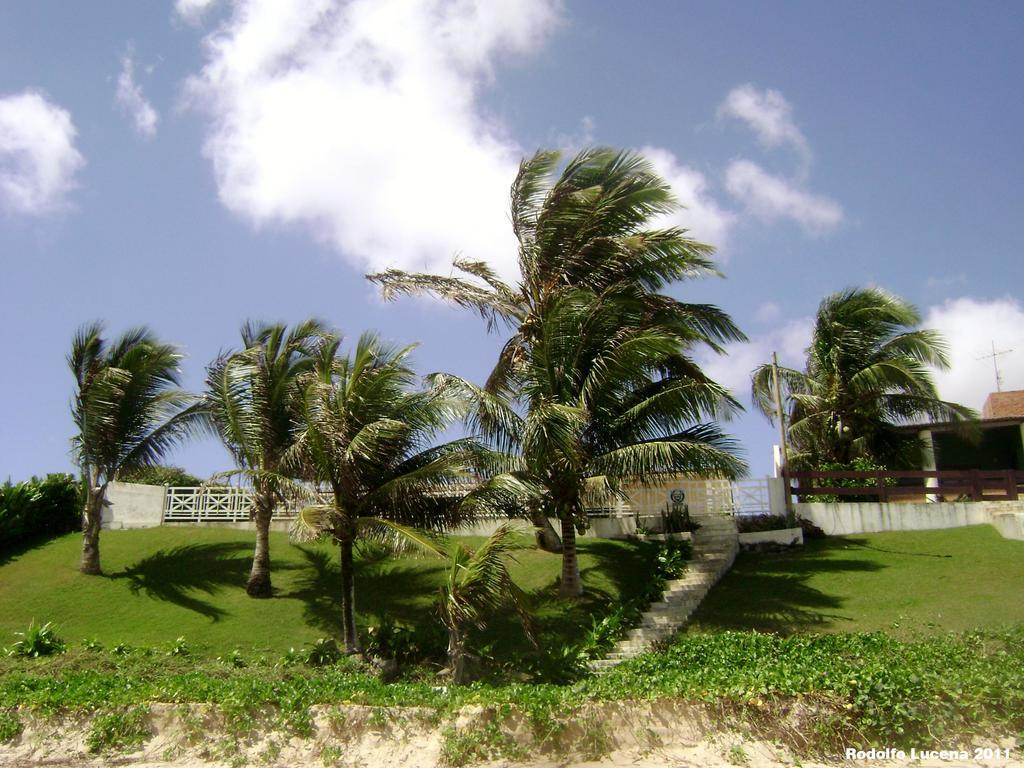What type of vegetation can be seen in the image? There are plants and trees in the image. What is on the ground in the image? There is grass on the ground in the image. What type of barrier is visible in the image? There is fencing visible in the image. What else can be seen in the image besides vegetation and fencing? There are other objects in the image. How would you describe the sky in the image? The sky is cloudy in the image. Are there any police officers playing baseball in the image? There is no indication of police officers or a baseball game in the image. 